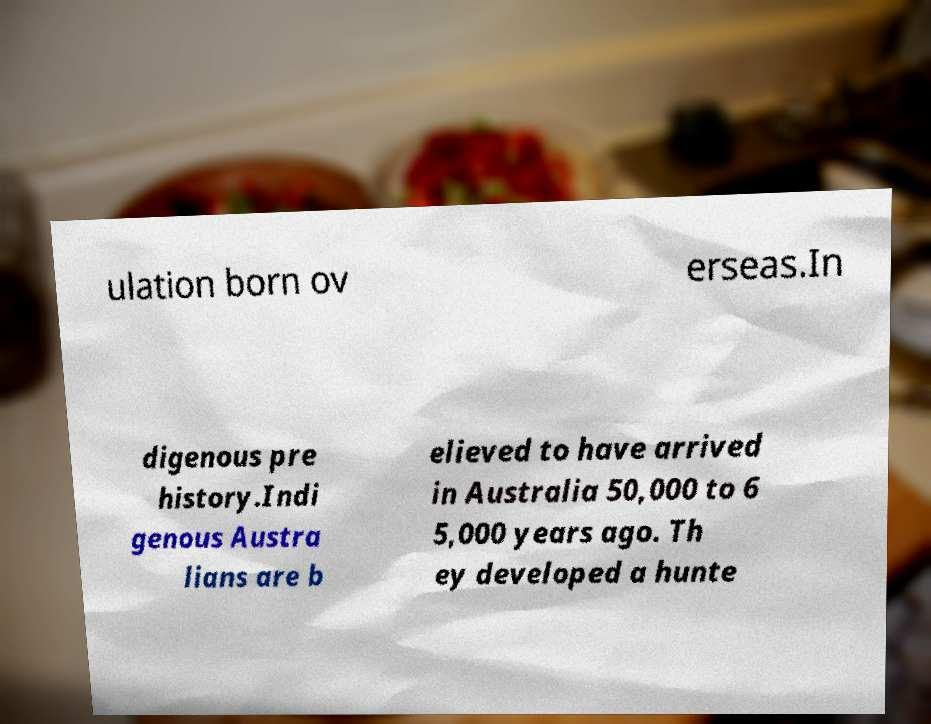I need the written content from this picture converted into text. Can you do that? ulation born ov erseas.In digenous pre history.Indi genous Austra lians are b elieved to have arrived in Australia 50,000 to 6 5,000 years ago. Th ey developed a hunte 